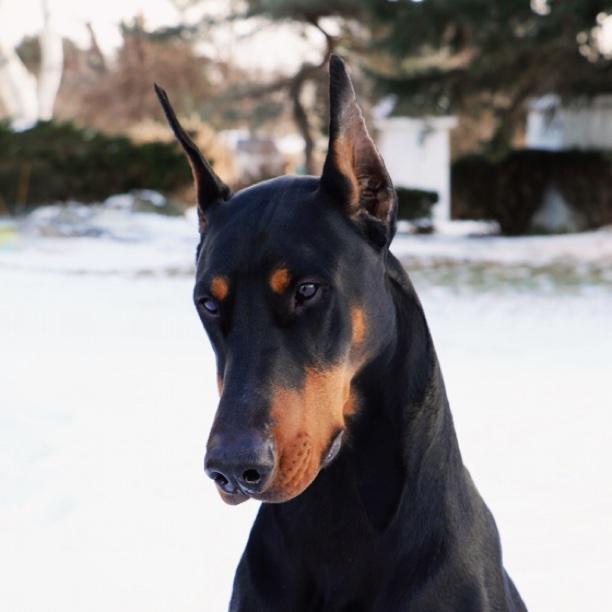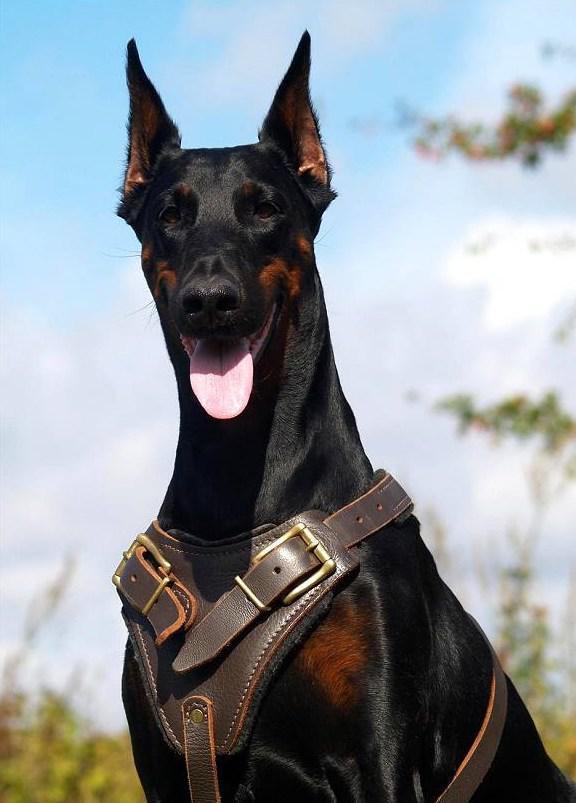The first image is the image on the left, the second image is the image on the right. Considering the images on both sides, is "All dogs are pointy-eared adult dobermans, and at least seven dogs in total are shown." valid? Answer yes or no. No. The first image is the image on the left, the second image is the image on the right. Evaluate the accuracy of this statement regarding the images: "The right image contains exactly five dogs.". Is it true? Answer yes or no. No. 